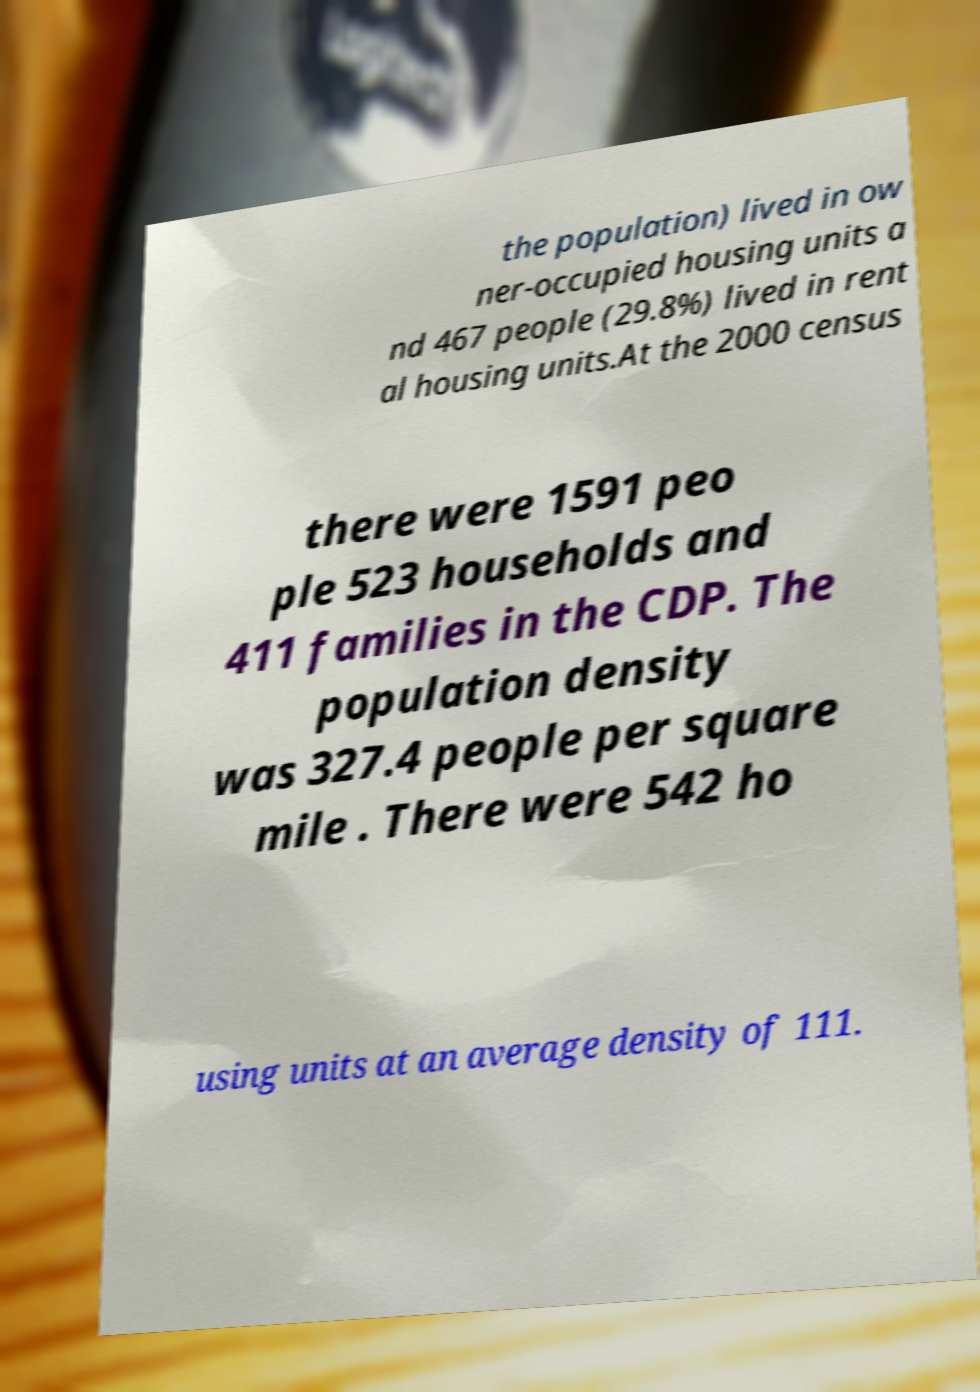Could you assist in decoding the text presented in this image and type it out clearly? the population) lived in ow ner-occupied housing units a nd 467 people (29.8%) lived in rent al housing units.At the 2000 census there were 1591 peo ple 523 households and 411 families in the CDP. The population density was 327.4 people per square mile . There were 542 ho using units at an average density of 111. 